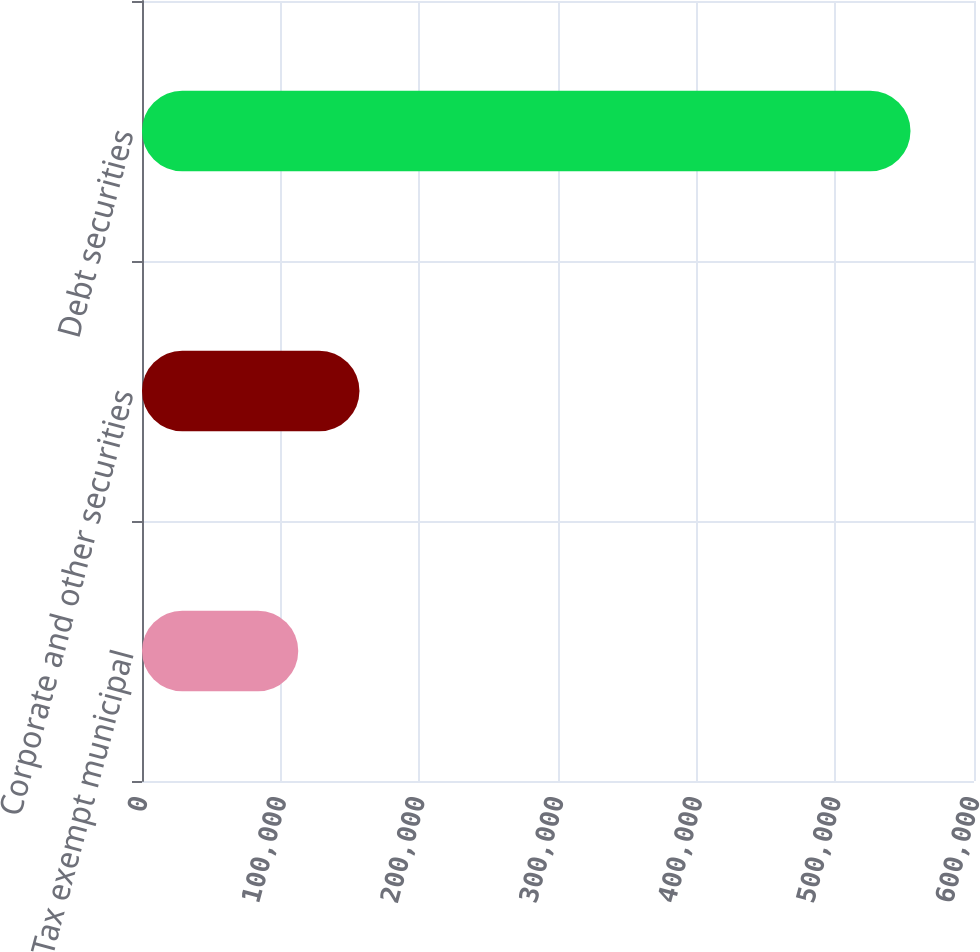Convert chart. <chart><loc_0><loc_0><loc_500><loc_500><bar_chart><fcel>Tax exempt municipal<fcel>Corporate and other securities<fcel>Debt securities<nl><fcel>112684<fcel>156836<fcel>554208<nl></chart> 